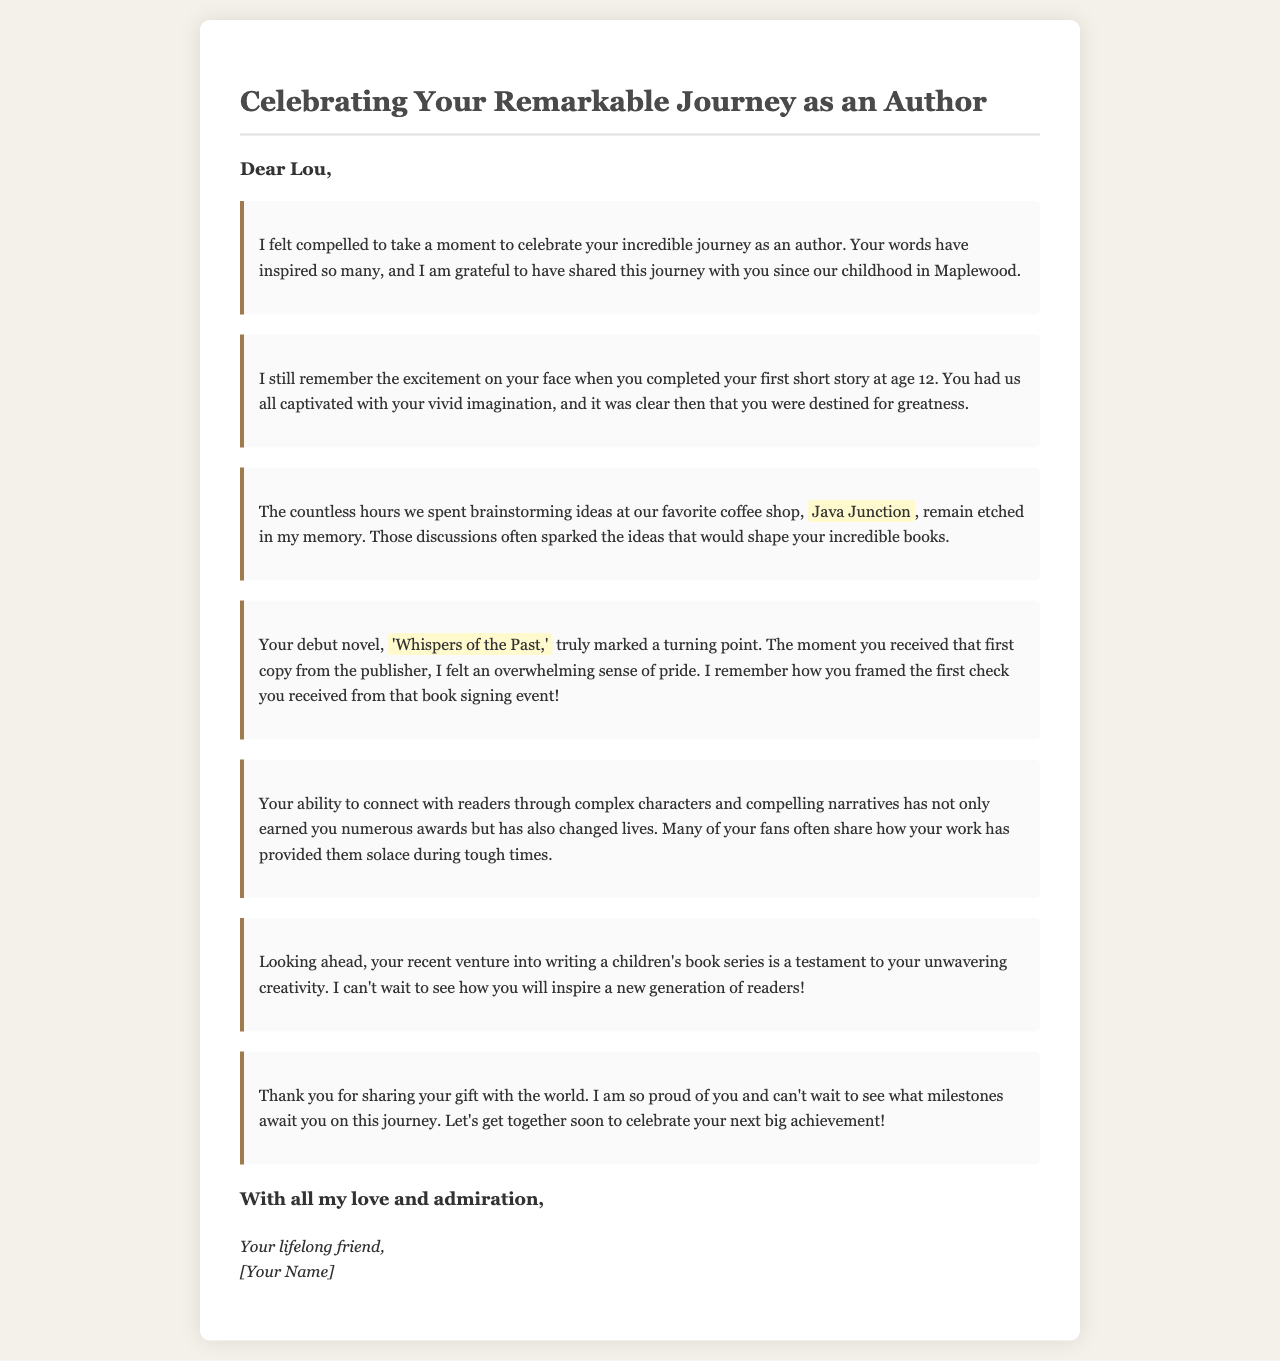what is the title of the letter? The title of the letter is prominently displayed at the top of the document, celebrating Lou's journey as an author.
Answer: Celebrating Your Remarkable Journey as an Author how old was Lou when they completed their first short story? The document mentions that Lou completed their first short story at age 12.
Answer: 12 what is the name of Lou's debut novel? The document specifies the title of Lou's debut novel within the text.
Answer: Whispers of the Past where did Lou and the author spend time brainstorming ideas? The document refers to a specific place where Lou and the author often discussed ideas.
Answer: Java Junction what recent venture is mentioned regarding Lou's writing? The document discusses Lou's recent undertaking in a new area of writing.
Answer: children's book series how does Lou's writing impact their readers? The document describes the effect of Lou's writing on their readers, mentioning a specific outcome.
Answer: provided them solace during tough times what emotion does the author express regarding Lou's journey? The author conveys a specific sentiment about Lou's accomplishments throughout the letter.
Answer: pride what does the author hope for in Lou's future? The document expresses a desire about what the author anticipates for Lou's work moving forward.
Answer: to see what milestones await you on this journey 